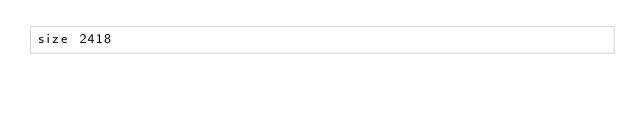Convert code to text. <code><loc_0><loc_0><loc_500><loc_500><_C#_>size 2418
</code> 